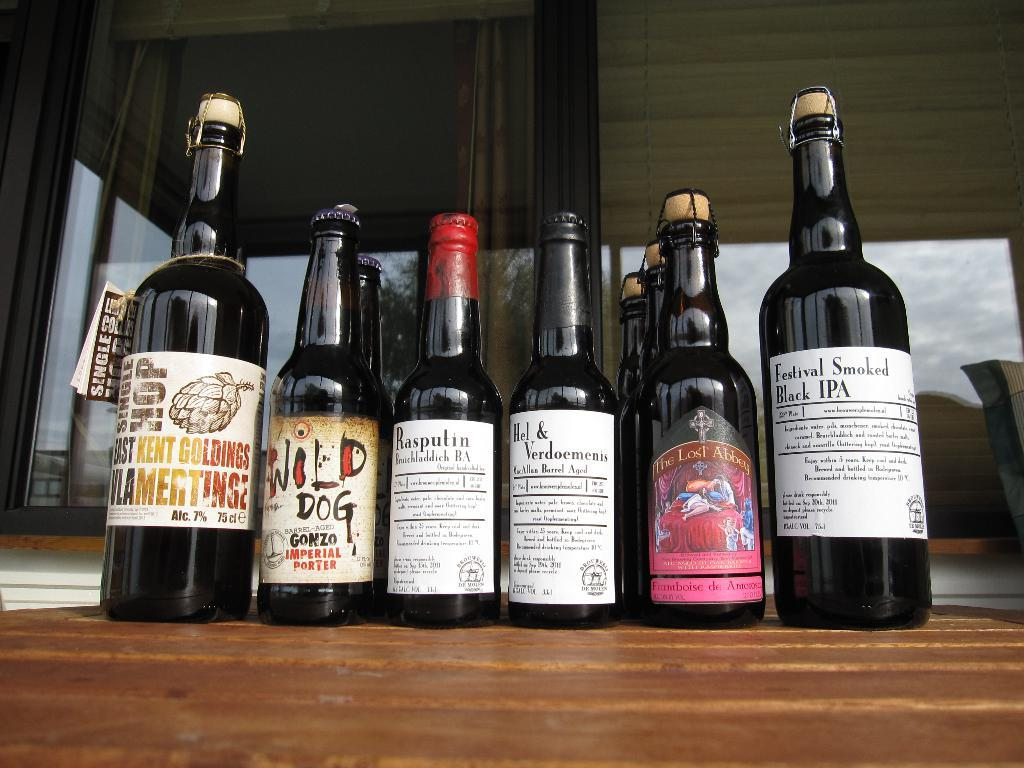<image>
Relay a brief, clear account of the picture shown. A row of beer bottles are on a wooden table and one of them says Festival Smoked Black IPA. 